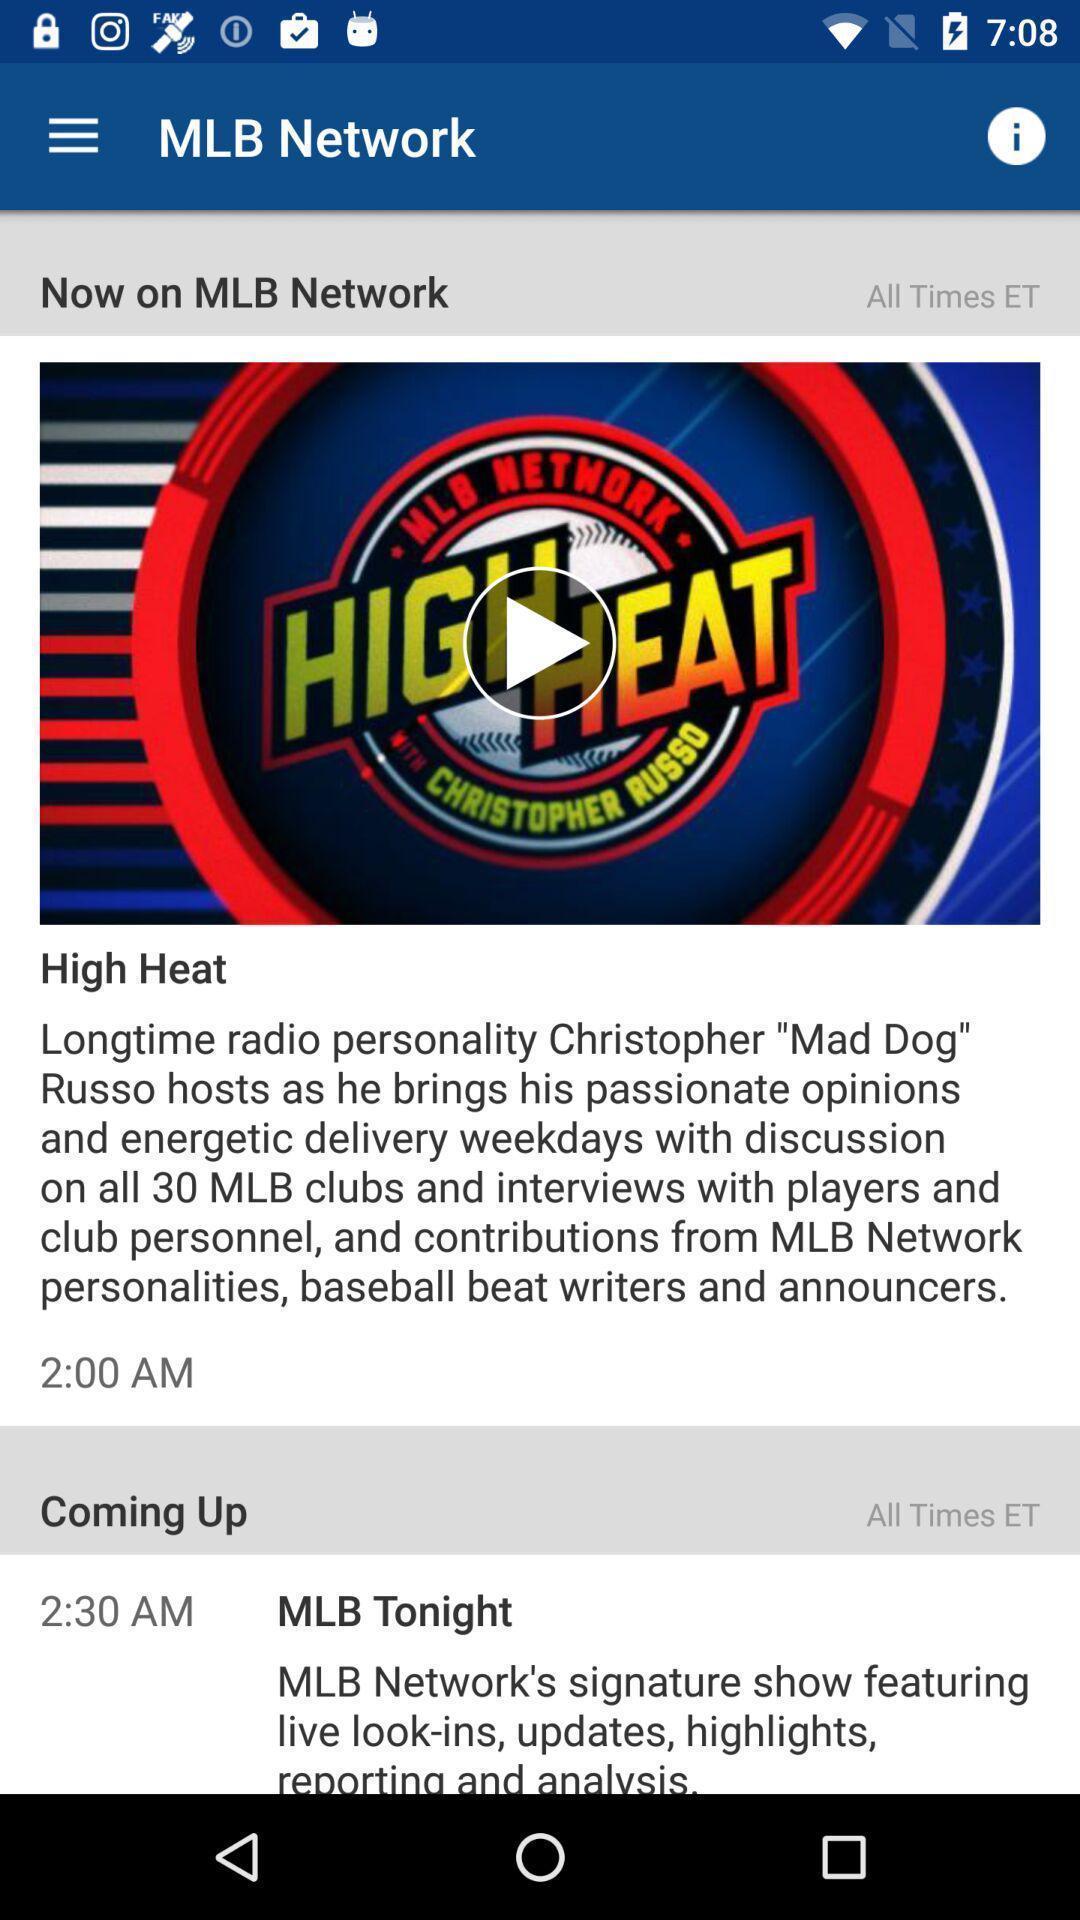Tell me what you see in this picture. Screen shows upcoming networks on a device. 